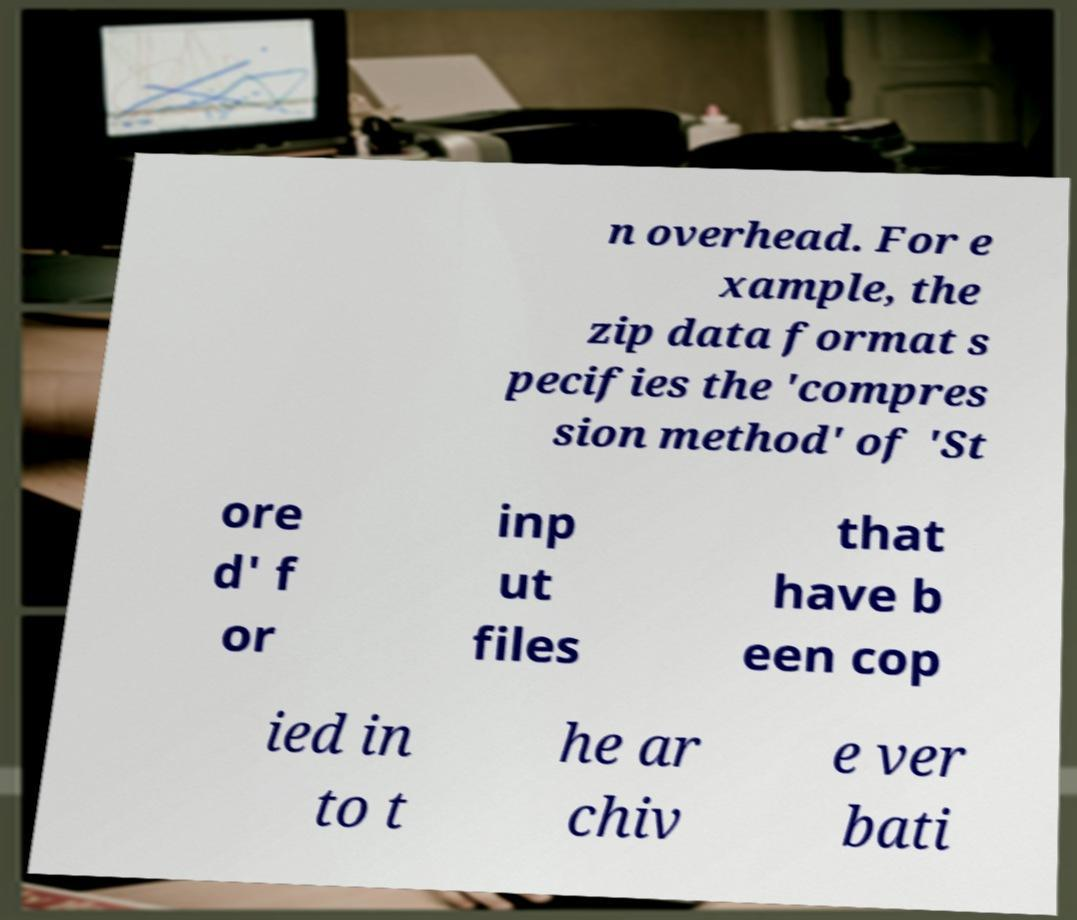For documentation purposes, I need the text within this image transcribed. Could you provide that? n overhead. For e xample, the zip data format s pecifies the 'compres sion method' of 'St ore d' f or inp ut files that have b een cop ied in to t he ar chiv e ver bati 